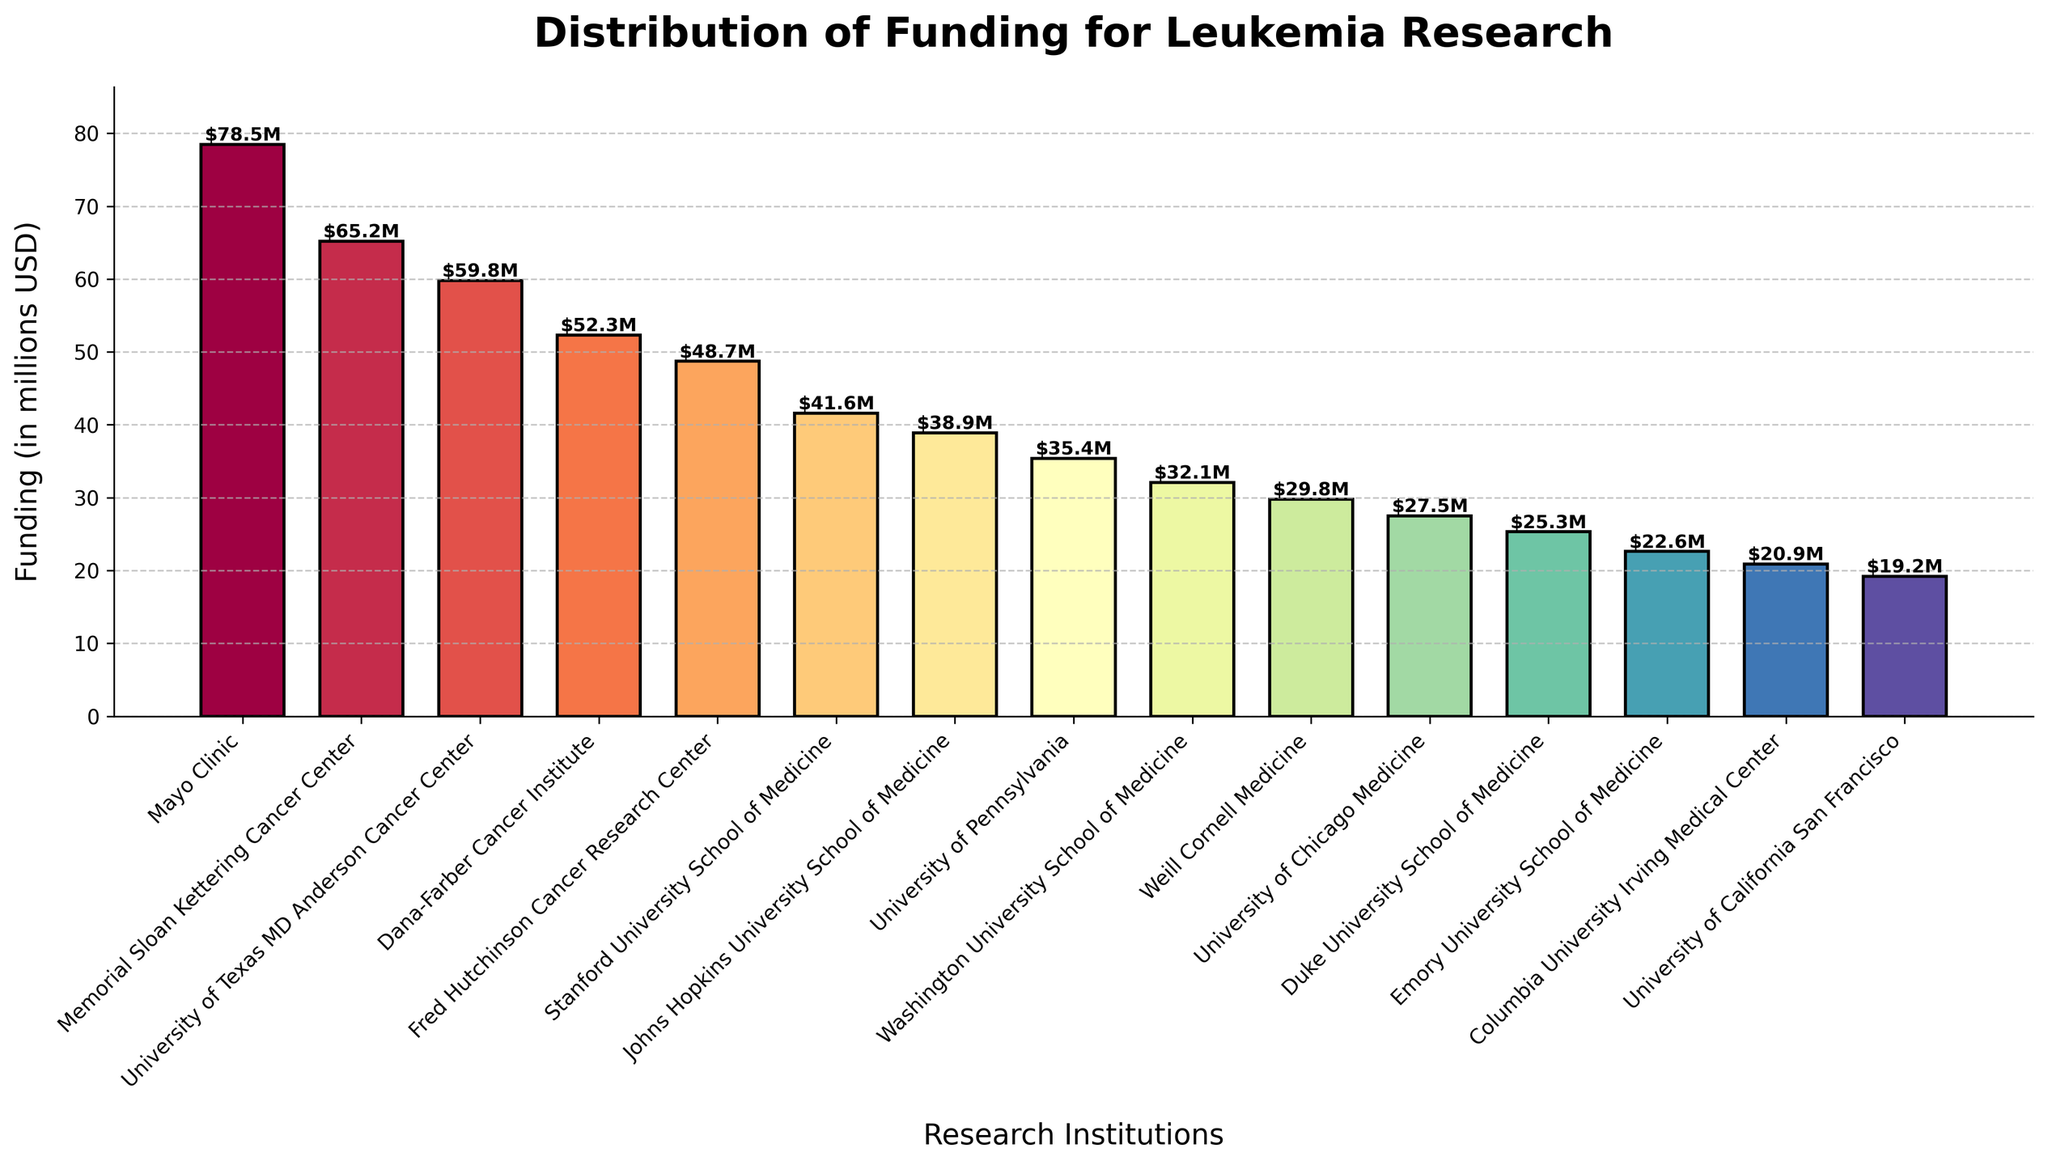Which research institution received the highest funding? The Mayo Clinic's bar is the tallest in the chart, indicating the highest funding amount.
Answer: Mayo Clinic Which institution received more funding: Dana-Farber Cancer Institute or Stanford University School of Medicine? Comparing the heights of the bars, Dana-Farber Cancer Institute's bar is taller than Stanford University's, indicating higher funding.
Answer: Dana-Farber Cancer Institute What's the total funding received by the top 3 institutions? The funding for the top 3 institutions (Mayo Clinic, Memorial Sloan Kettering, and University of Texas MD Anderson) are $78.5M, $65.2M, and $59.8M. Summing these gives: $78.5M + $65.2M + $59.8M = $203.5M.
Answer: $203.5M What is the difference in funding between Johns Hopkins University School of Medicine and University of Pennsylvania? The funding amounts are $38.9M for Johns Hopkins and $35.4M for University of Pennsylvania. The difference is $38.9M - $35.4M = $3.5M.
Answer: $3.5M Which institutions received less than $30M in funding? Institutions with bars shorter than those up to $30M are: Weill Cornell Medicine, University of Chicago Medicine, Duke University School of Medicine, Emory University School of Medicine, Columbia University Irving Medical Center, and University of California San Francisco.
Answer: Weill Cornell Medicine, University of Chicago Medicine, Duke University School of Medicine, Emory University School of Medicine, Columbia University Irving Medical Center, University of California San Francisco What is the average funding received by all institutions? Summing up all the funding amounts: $78.5M + $65.2M + $59.8M + $52.3M + $48.7M + $41.6M + $38.9M + $35.4M + $32.1M + $29.8M + $27.5M + $25.3M + $22.6M + $20.9M + $19.2M = $597.8M. Dividing by the number of institutions (15), we get $597.8M / 15 ≈ $39.85M.
Answer: $39.85M Is the funding of University of Texas MD Anderson Cancer Center closer to Mayo Clinic or Memorial Sloan Kettering Cancer Center? Comparing the differences, Mayo Clinic's funding is $78.5M and Memorial Sloan Kettering's is $65.2M. University of Texas MD Anderson's is $59.8M:
The differences:
$78.5M - $59.8M = $18.7M
$65.2M - $59.8M = $5.4M.
Thus, it is closer to Memorial Sloan Kettering Cancer Center.
Answer: Memorial Sloan Kettering Cancer Center What is the combined funding for institutions that received more than $50M? Institutions that received more than $50M funding are: Mayo Clinic ($78.5M), Memorial Sloan Kettering ($65.2M), University of Texas MD Anderson ($59.8M), and Dana-Farber ($52.3M). Summing these amounts gives: $78.5M + $65.2M + $59.8M + $52.3M = $255.8M.
Answer: $255.8M 